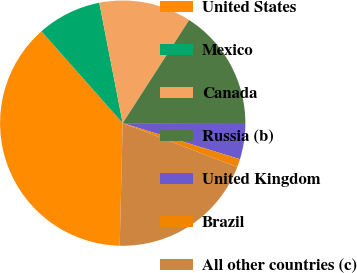Convert chart. <chart><loc_0><loc_0><loc_500><loc_500><pie_chart><fcel>United States<fcel>Mexico<fcel>Canada<fcel>Russia (b)<fcel>United Kingdom<fcel>Brazil<fcel>All other countries (c)<nl><fcel>38.08%<fcel>8.47%<fcel>12.17%<fcel>15.87%<fcel>4.77%<fcel>1.07%<fcel>19.57%<nl></chart> 